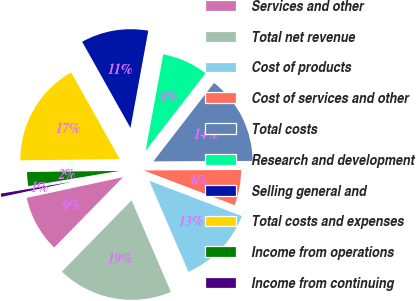Convert chart. <chart><loc_0><loc_0><loc_500><loc_500><pie_chart><fcel>Services and other<fcel>Total net revenue<fcel>Cost of products<fcel>Cost of services and other<fcel>Total costs<fcel>Research and development<fcel>Selling general and<fcel>Total costs and expenses<fcel>Income from operations<fcel>Income from continuing<nl><fcel>9.31%<fcel>18.78%<fcel>12.74%<fcel>5.88%<fcel>14.45%<fcel>7.59%<fcel>11.02%<fcel>17.06%<fcel>2.44%<fcel>0.73%<nl></chart> 